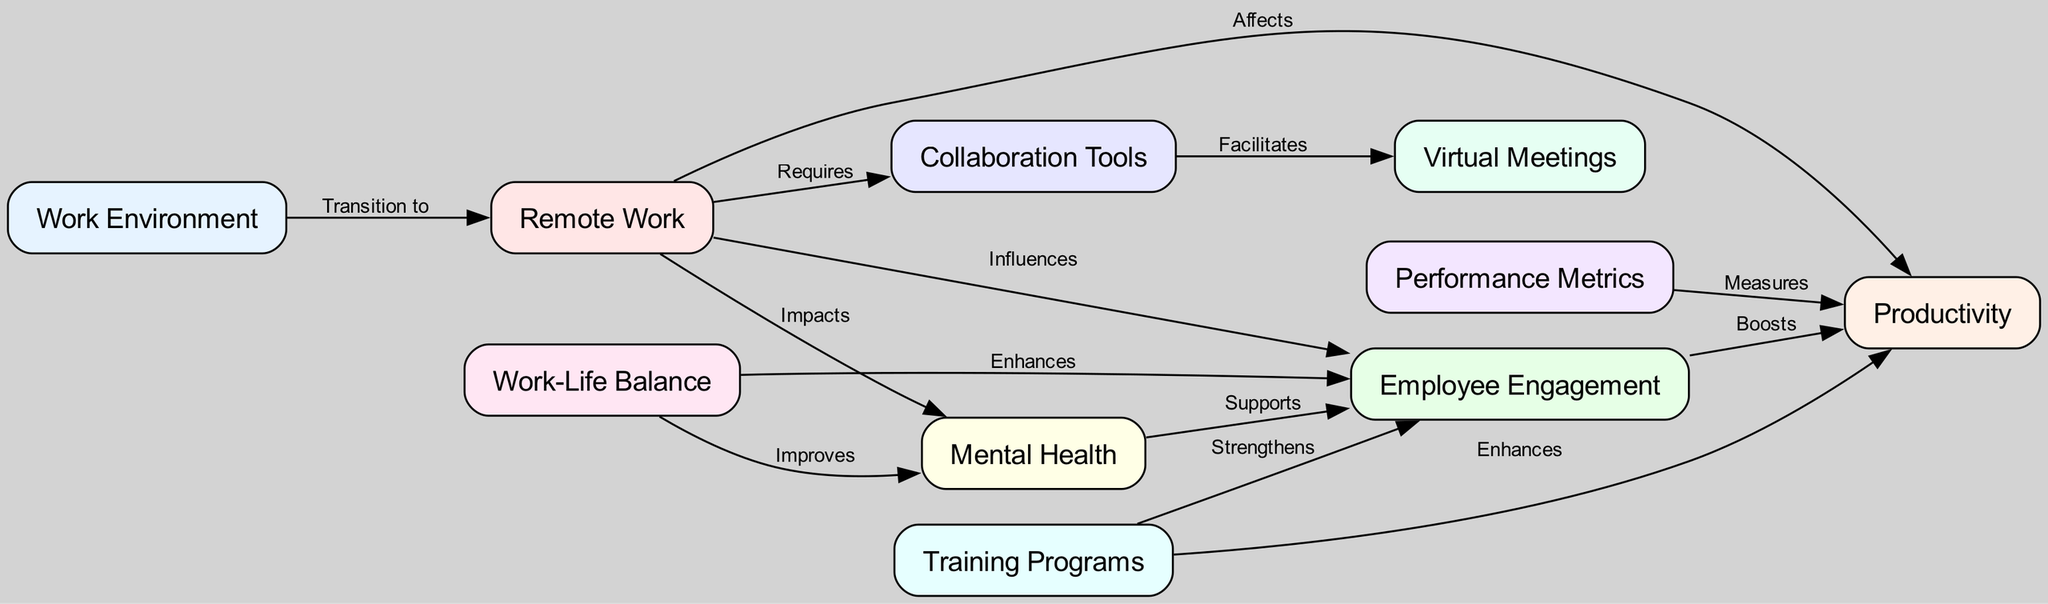What are the total number of nodes in the diagram? The diagram consists of 10 distinct nodes representing various aspects of workforce dynamics in remote work environments. So, counting all the unique labels listed, there are ten nodes in total.
Answer: 10 Which node influences employee engagement? The diagram shows that the node "remote work" has a directed edge pointing to "employee engagement" with the label "Influences", indicating that remote work has an effect on employee engagement levels.
Answer: Remote Work What relationship does mental health have with employee engagement? According to the diagram, there is an edge from "mental health" to "employee engagement" labeled "Supports", suggesting that mental health plays a role in enhancing employee engagement in remote work environments.
Answer: Supports Which two nodes are connected by the edge that is labeled "Facilitates"? The edge labeled "Facilitates" connects the nodes "collaboration tools" and "virtual meetings", indicating that the implementation of collaboration tools aids in conducting virtual meetings.
Answer: Collaboration Tools and Virtual Meetings How does work-life balance impact mental health? The diagram illustrates a relationship where "work-life balance" has a directed edge to "mental health" labeled "Improves". This indicates that maintaining a healthy work-life balance positively affects mental health.
Answer: Improves What effect do training programs have on productivity? The diagram displays an edge from "training programs" to "productivity" labeled "Enhances", demonstrating that implementing training programs can contribute to an increase in productivity metrics for employees.
Answer: Enhances Which element directly impacts productivity, according to the diagram? The diagram shows that both "remote work" and "employee engagement" have direct edges leading to "productivity". Therefore, both elements directly affect productivity outcomes.
Answer: Remote Work and Employee Engagement What is required for remote work according to the diagram? The directed edge from "remote work" to "collaboration tools" is labeled "Requires", indicating that collaboration tools are necessary for effective remote work settings.
Answer: Collaboration Tools Which nodes are involved in measuring productivity? The diagram specifies that "performance metrics" has a directed edge to "productivity" labeled "Measures", showing it as the element involved in productivity measurement.
Answer: Performance Metrics 